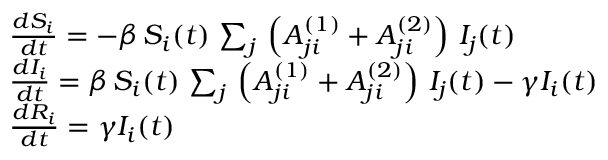Convert formula to latex. <formula><loc_0><loc_0><loc_500><loc_500>\begin{array} { l } { \frac { d S _ { i } } { d t } = - \beta \, S _ { i } ( t ) \, \sum _ { j } \, \left ( A _ { j i } ^ { ( 1 ) } + A _ { j i } ^ { ( 2 ) } \right ) \, I _ { j } ( t ) } \\ { \frac { d I _ { i } } { d t } = \beta \, S _ { i } ( t ) \, \sum _ { j } \, \left ( A _ { j i } ^ { ( 1 ) } + A _ { j i } ^ { ( 2 ) } \right ) \, I _ { j } ( t ) - \gamma I _ { i } ( t ) } \\ { \frac { d R _ { i } } { d t } = \gamma I _ { i } ( t ) } \end{array}</formula> 